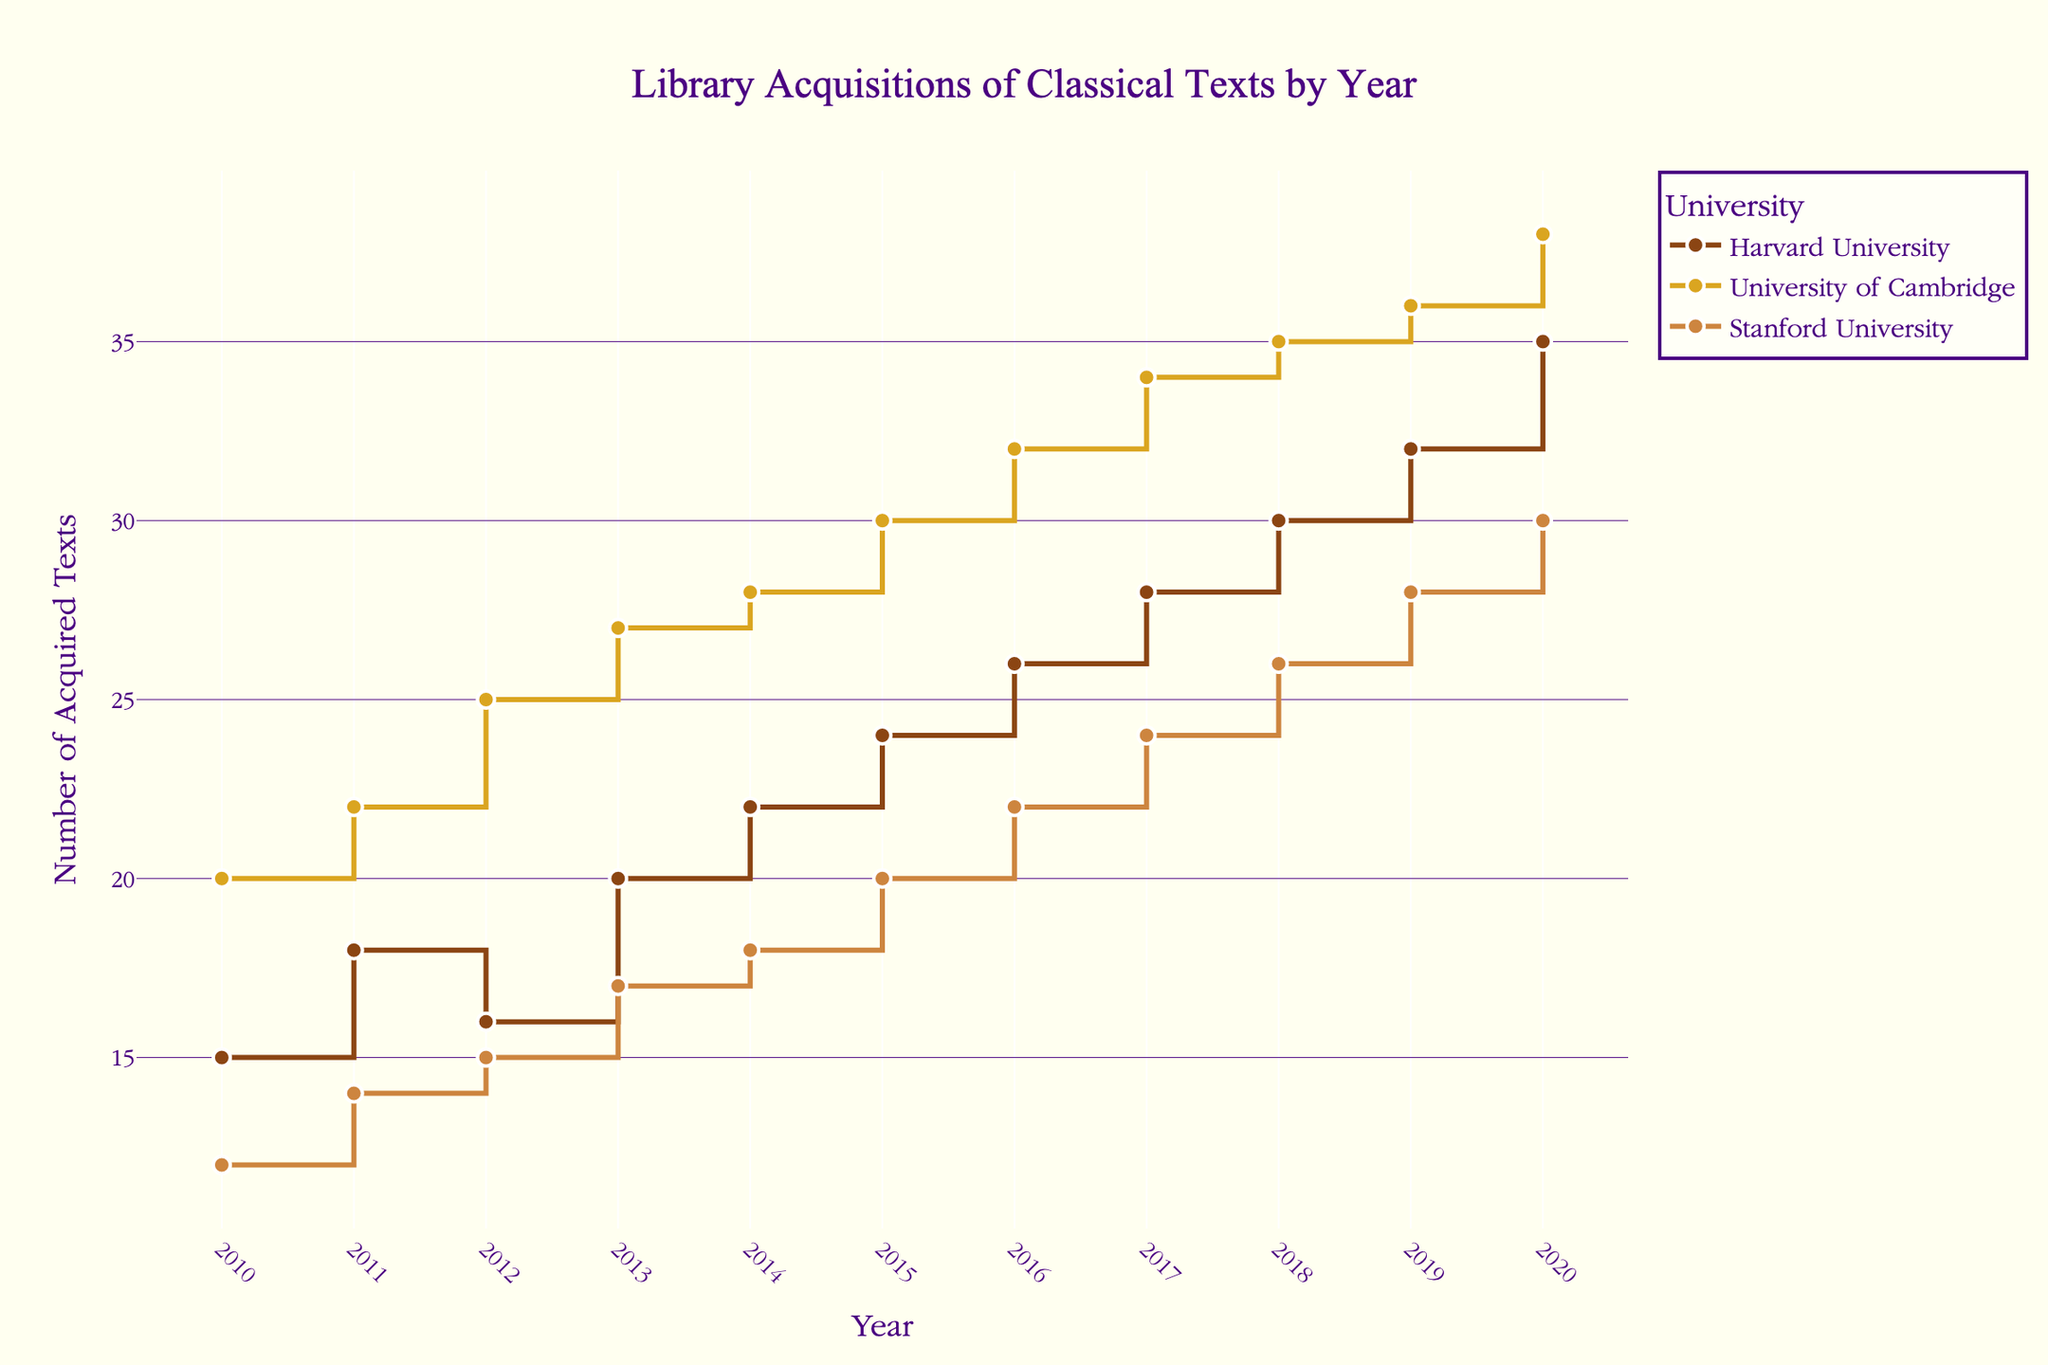What is the title of the plot? The title is usually placed at the top of the figure. In this plot, it reads "Library Acquisitions of Classical Texts by Year".
Answer: Library Acquisitions of Classical Texts by Year Which university had the highest number of acquired texts in 2020? Locate the year 2020 on the x-axis and compare the y-values (number of acquired texts) for the three universities. Cambridge has the highest value at 38.
Answer: University of Cambridge How many texts did Harvard University acquire in 2015? Find the year 2015 on the x-axis and trace it up to the Harvard line, which is marked by a step upward at 24 acquired texts.
Answer: 24 What is the average number of texts acquired by Stanford University over the displayed years? Sum the values for Stanford University from 2010 to 2020 (12, 14, 15, 17, 18, 20, 22, 24, 26, 28, 30) and divide by the number of years (11). The sum is 226. Therefore, the average is 226/11 = 20.545.
Answer: 20.55 What is the difference in the number of texts acquired between Harvard and Stanford in 2019? In 2019, Harvard acquired 32 texts and Stanford acquired 28. The difference is 32 - 28.
Answer: 4 Which university saw the greatest increase in acquisitions from 2010 to 2020? Determine the difference between 2020 and 2010 acquisitions for each university: Harvard (35 - 15 = 20), Cambridge (38 - 20 = 18), and Stanford (30 - 12 = 18). Harvard saw the greatest increase.
Answer: Harvard University Between 2010 and 2020, which year saw the highest combined total acquisitions across all universities? Calculate total acquisitions for all universities per year, find the year with the highest total: 2020 totals Harvard (35) + Cambridge (38) + Stanford (30) = 103.
Answer: 2020 Which university's number of acquisitions remained the highest most consistently over the years? Look at every year from 2010 to 2020 and observe which university's data points more frequently appear as the highest. Cambridge remains highest consistently.
Answer: University of Cambridge How did University of Cambridge's acquisitions trend between 2015 - 2016? What is the shape of the line section? From 2015 to 2016, University of Cambridge's acquisitions increased from 30 to 32. This appears as an upward step on the plot's 'step' line shape.
Answer: Increase, upward step 